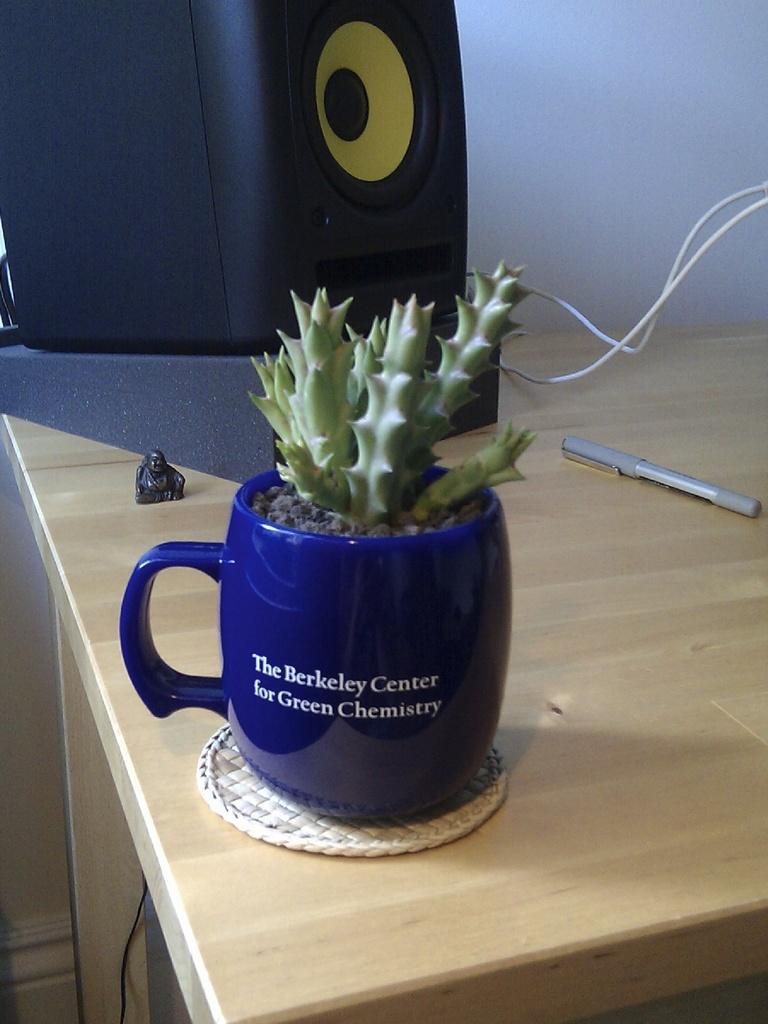In one or two sentences, can you explain what this image depicts? In this image I can see a table and on it I can see a plant in a blue colour mug. Behind it I can see a mini sculpture, a black colour speaker, two wires and a pen. 